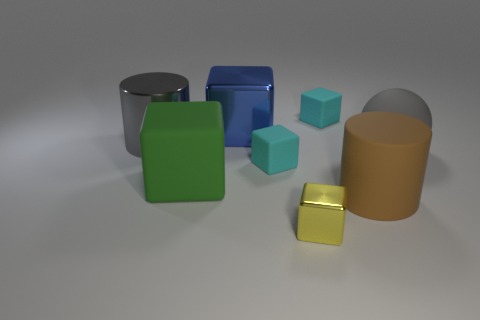There is a metallic cylinder that is the same size as the brown thing; what is its color?
Provide a succinct answer. Gray. Are there any matte balls that have the same color as the big shiny cylinder?
Give a very brief answer. Yes. There is a cyan thing in front of the metal cylinder; is it the same shape as the gray object that is on the right side of the big blue object?
Your response must be concise. No. What is the size of the matte ball that is the same color as the large metal cylinder?
Provide a succinct answer. Large. What number of other things are there of the same size as the brown matte thing?
Offer a very short reply. 4. Is the color of the big shiny cylinder the same as the big rubber object that is on the right side of the brown cylinder?
Your response must be concise. Yes. Is the number of small matte things that are in front of the yellow shiny block less than the number of large blocks that are in front of the big gray ball?
Keep it short and to the point. Yes. The shiny thing that is to the right of the gray shiny object and behind the green matte thing is what color?
Offer a terse response. Blue. Is the size of the gray metallic cylinder the same as the metal cube that is behind the small yellow metallic block?
Your response must be concise. Yes. The big gray shiny object behind the big green rubber cube has what shape?
Provide a short and direct response. Cylinder. 